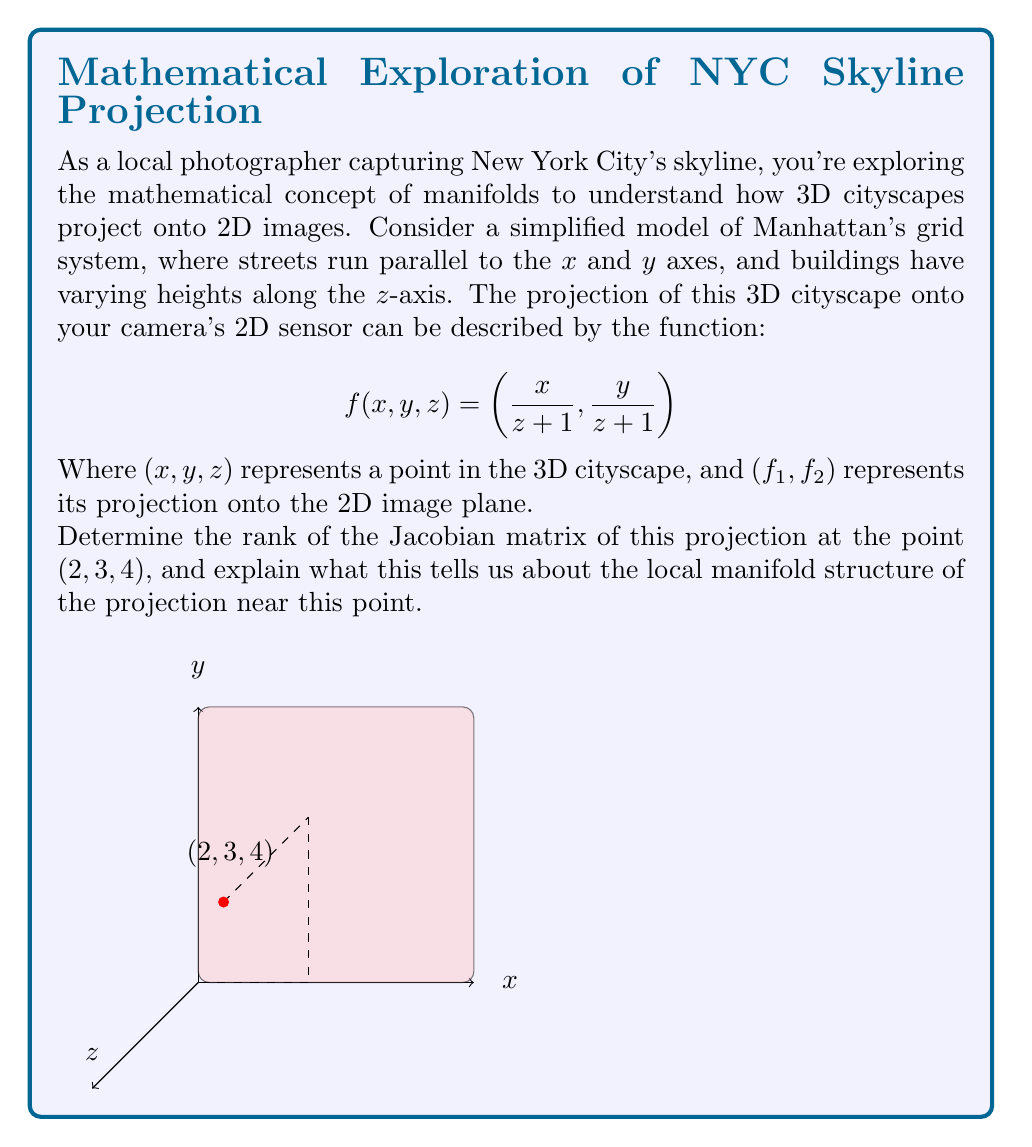Show me your answer to this math problem. To determine the manifold structure of the projection, we need to calculate the Jacobian matrix and its rank:

1) First, let's compute the partial derivatives of $f_1$ and $f_2$:

   $$\frac{\partial f_1}{\partial x} = \frac{1}{z+1}, \quad \frac{\partial f_1}{\partial y} = 0, \quad \frac{\partial f_1}{\partial z} = -\frac{x}{(z+1)^2}$$
   $$\frac{\partial f_2}{\partial x} = 0, \quad \frac{\partial f_2}{\partial y} = \frac{1}{z+1}, \quad \frac{\partial f_2}{\partial z} = -\frac{y}{(z+1)^2}$$

2) The Jacobian matrix at the point $(2, 3, 4)$ is:

   $$J = \begin{bmatrix}
   \frac{1}{5} & 0 & -\frac{2}{25} \\
   0 & \frac{1}{5} & -\frac{3}{25}
   \end{bmatrix}$$

3) To find the rank of this matrix, we need to determine the number of linearly independent rows or columns. We can see that the first two columns are clearly linearly independent.

4) The rank of a matrix is the number of non-zero rows in its row echelon form. Let's perform row reduction:

   $$\begin{bmatrix}
   \frac{1}{5} & 0 & -\frac{2}{25} \\
   0 & \frac{1}{5} & -\frac{3}{25}
   \end{bmatrix}$$

   This matrix is already in row echelon form, and it has 2 non-zero rows.

5) Therefore, the rank of the Jacobian matrix at (2, 3, 4) is 2.

This result tells us that the projection is locally a smooth 2-dimensional manifold near the point (2, 3, 4). The rank being 2 (which is less than the dimension of the domain, 3) indicates that the projection is not invertible in a neighborhood of this point, which is expected as we're projecting from 3D to 2D. However, it also shows that the projection preserves some local structure, as it maps to a 2D space without collapsing to a lower dimension.
Answer: Rank 2; locally a smooth 2D manifold 